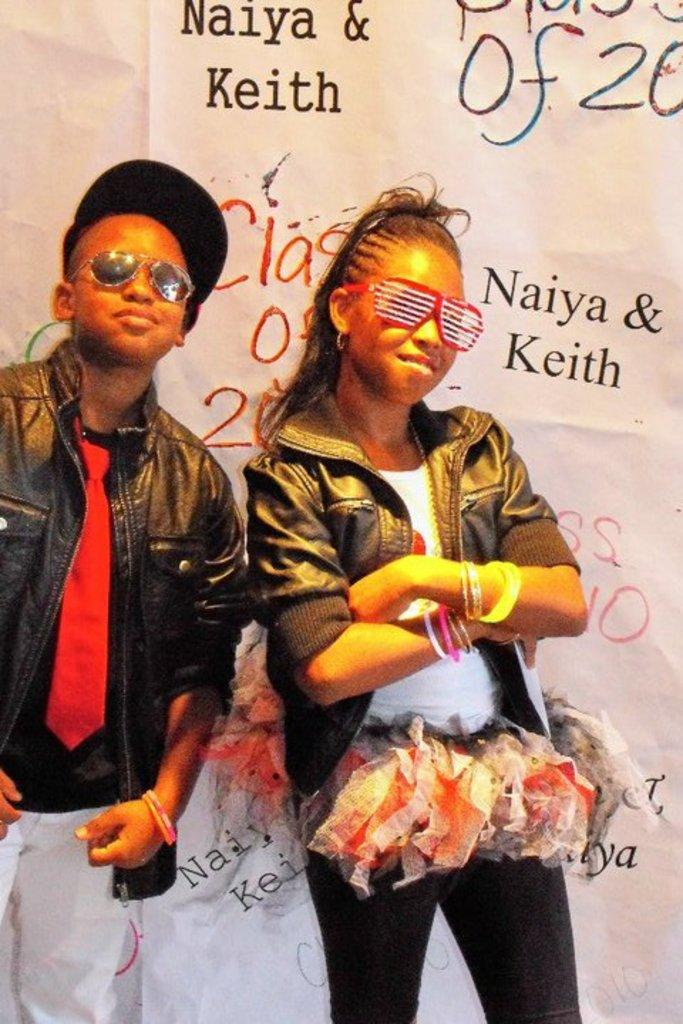How many people are in the image? There are two people in the image, a boy and a girl. What are the boy and the girl wearing? Both the boy and the girl are wearing jackets and specs. What can be seen in the background of the image? There is a paper in the background of the image. What is written or visible on the paper? Text is visible on the paper. How many frogs can be seen on the back of the vessel in the image? There is no vessel or frogs present in the image. 